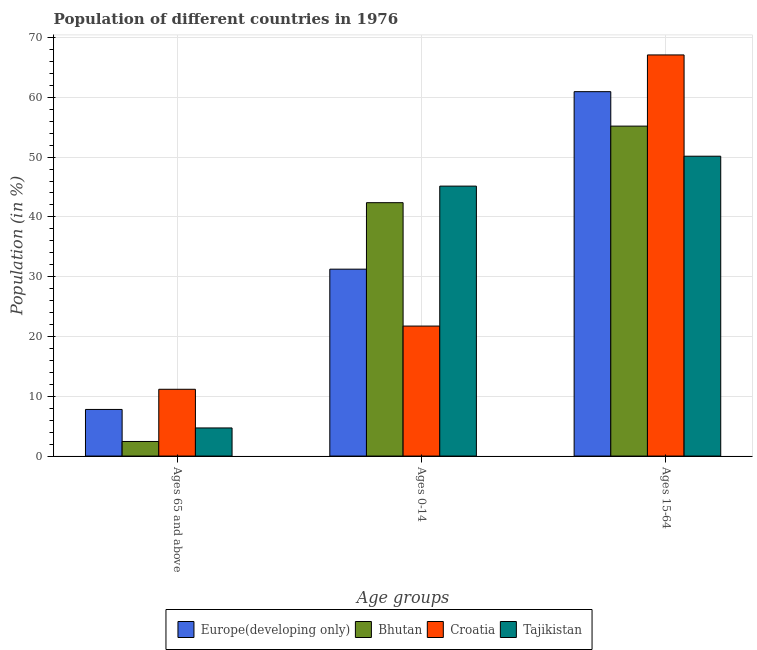How many groups of bars are there?
Keep it short and to the point. 3. Are the number of bars per tick equal to the number of legend labels?
Keep it short and to the point. Yes. How many bars are there on the 1st tick from the left?
Make the answer very short. 4. What is the label of the 2nd group of bars from the left?
Your response must be concise. Ages 0-14. What is the percentage of population within the age-group 15-64 in Tajikistan?
Your response must be concise. 50.15. Across all countries, what is the maximum percentage of population within the age-group of 65 and above?
Your answer should be compact. 11.17. Across all countries, what is the minimum percentage of population within the age-group 15-64?
Keep it short and to the point. 50.15. In which country was the percentage of population within the age-group of 65 and above maximum?
Offer a terse response. Croatia. In which country was the percentage of population within the age-group 0-14 minimum?
Ensure brevity in your answer.  Croatia. What is the total percentage of population within the age-group 15-64 in the graph?
Offer a terse response. 233.36. What is the difference between the percentage of population within the age-group 15-64 in Bhutan and that in Croatia?
Provide a short and direct response. -11.91. What is the difference between the percentage of population within the age-group of 65 and above in Tajikistan and the percentage of population within the age-group 0-14 in Europe(developing only)?
Offer a very short reply. -26.55. What is the average percentage of population within the age-group 15-64 per country?
Your answer should be compact. 58.34. What is the difference between the percentage of population within the age-group 15-64 and percentage of population within the age-group of 65 and above in Bhutan?
Offer a very short reply. 52.74. What is the ratio of the percentage of population within the age-group of 65 and above in Croatia to that in Europe(developing only)?
Keep it short and to the point. 1.43. Is the difference between the percentage of population within the age-group of 65 and above in Bhutan and Tajikistan greater than the difference between the percentage of population within the age-group 0-14 in Bhutan and Tajikistan?
Your answer should be very brief. Yes. What is the difference between the highest and the second highest percentage of population within the age-group of 65 and above?
Make the answer very short. 3.37. What is the difference between the highest and the lowest percentage of population within the age-group 0-14?
Your answer should be very brief. 23.41. Is the sum of the percentage of population within the age-group of 65 and above in Croatia and Europe(developing only) greater than the maximum percentage of population within the age-group 15-64 across all countries?
Ensure brevity in your answer.  No. What does the 3rd bar from the left in Ages 65 and above represents?
Provide a short and direct response. Croatia. What does the 1st bar from the right in Ages 65 and above represents?
Keep it short and to the point. Tajikistan. How many bars are there?
Provide a short and direct response. 12. Are all the bars in the graph horizontal?
Your response must be concise. No. What is the difference between two consecutive major ticks on the Y-axis?
Offer a very short reply. 10. Are the values on the major ticks of Y-axis written in scientific E-notation?
Give a very brief answer. No. Does the graph contain any zero values?
Provide a short and direct response. No. Where does the legend appear in the graph?
Give a very brief answer. Bottom center. What is the title of the graph?
Give a very brief answer. Population of different countries in 1976. Does "Tunisia" appear as one of the legend labels in the graph?
Offer a terse response. No. What is the label or title of the X-axis?
Give a very brief answer. Age groups. What is the label or title of the Y-axis?
Ensure brevity in your answer.  Population (in %). What is the Population (in %) of Europe(developing only) in Ages 65 and above?
Make the answer very short. 7.8. What is the Population (in %) in Bhutan in Ages 65 and above?
Make the answer very short. 2.44. What is the Population (in %) in Croatia in Ages 65 and above?
Provide a succinct answer. 11.17. What is the Population (in %) in Tajikistan in Ages 65 and above?
Your answer should be compact. 4.7. What is the Population (in %) in Europe(developing only) in Ages 0-14?
Make the answer very short. 31.26. What is the Population (in %) in Bhutan in Ages 0-14?
Give a very brief answer. 42.38. What is the Population (in %) of Croatia in Ages 0-14?
Offer a very short reply. 21.74. What is the Population (in %) of Tajikistan in Ages 0-14?
Ensure brevity in your answer.  45.15. What is the Population (in %) of Europe(developing only) in Ages 15-64?
Offer a very short reply. 60.94. What is the Population (in %) of Bhutan in Ages 15-64?
Provide a short and direct response. 55.18. What is the Population (in %) of Croatia in Ages 15-64?
Your answer should be compact. 67.09. What is the Population (in %) in Tajikistan in Ages 15-64?
Provide a succinct answer. 50.15. Across all Age groups, what is the maximum Population (in %) in Europe(developing only)?
Provide a succinct answer. 60.94. Across all Age groups, what is the maximum Population (in %) in Bhutan?
Ensure brevity in your answer.  55.18. Across all Age groups, what is the maximum Population (in %) in Croatia?
Offer a terse response. 67.09. Across all Age groups, what is the maximum Population (in %) of Tajikistan?
Provide a short and direct response. 50.15. Across all Age groups, what is the minimum Population (in %) in Europe(developing only)?
Keep it short and to the point. 7.8. Across all Age groups, what is the minimum Population (in %) of Bhutan?
Provide a succinct answer. 2.44. Across all Age groups, what is the minimum Population (in %) in Croatia?
Provide a succinct answer. 11.17. Across all Age groups, what is the minimum Population (in %) of Tajikistan?
Your answer should be very brief. 4.7. What is the total Population (in %) in Bhutan in the graph?
Provide a short and direct response. 100. What is the difference between the Population (in %) of Europe(developing only) in Ages 65 and above and that in Ages 0-14?
Give a very brief answer. -23.46. What is the difference between the Population (in %) in Bhutan in Ages 65 and above and that in Ages 0-14?
Your answer should be very brief. -39.94. What is the difference between the Population (in %) in Croatia in Ages 65 and above and that in Ages 0-14?
Make the answer very short. -10.57. What is the difference between the Population (in %) of Tajikistan in Ages 65 and above and that in Ages 0-14?
Provide a succinct answer. -40.44. What is the difference between the Population (in %) of Europe(developing only) in Ages 65 and above and that in Ages 15-64?
Keep it short and to the point. -53.15. What is the difference between the Population (in %) of Bhutan in Ages 65 and above and that in Ages 15-64?
Offer a very short reply. -52.74. What is the difference between the Population (in %) of Croatia in Ages 65 and above and that in Ages 15-64?
Your response must be concise. -55.92. What is the difference between the Population (in %) in Tajikistan in Ages 65 and above and that in Ages 15-64?
Your response must be concise. -45.45. What is the difference between the Population (in %) in Europe(developing only) in Ages 0-14 and that in Ages 15-64?
Make the answer very short. -29.69. What is the difference between the Population (in %) in Bhutan in Ages 0-14 and that in Ages 15-64?
Offer a terse response. -12.8. What is the difference between the Population (in %) of Croatia in Ages 0-14 and that in Ages 15-64?
Keep it short and to the point. -45.35. What is the difference between the Population (in %) of Tajikistan in Ages 0-14 and that in Ages 15-64?
Provide a short and direct response. -5. What is the difference between the Population (in %) of Europe(developing only) in Ages 65 and above and the Population (in %) of Bhutan in Ages 0-14?
Keep it short and to the point. -34.58. What is the difference between the Population (in %) in Europe(developing only) in Ages 65 and above and the Population (in %) in Croatia in Ages 0-14?
Ensure brevity in your answer.  -13.94. What is the difference between the Population (in %) in Europe(developing only) in Ages 65 and above and the Population (in %) in Tajikistan in Ages 0-14?
Offer a terse response. -37.35. What is the difference between the Population (in %) in Bhutan in Ages 65 and above and the Population (in %) in Croatia in Ages 0-14?
Ensure brevity in your answer.  -19.3. What is the difference between the Population (in %) in Bhutan in Ages 65 and above and the Population (in %) in Tajikistan in Ages 0-14?
Provide a succinct answer. -42.71. What is the difference between the Population (in %) in Croatia in Ages 65 and above and the Population (in %) in Tajikistan in Ages 0-14?
Your response must be concise. -33.98. What is the difference between the Population (in %) in Europe(developing only) in Ages 65 and above and the Population (in %) in Bhutan in Ages 15-64?
Provide a succinct answer. -47.38. What is the difference between the Population (in %) in Europe(developing only) in Ages 65 and above and the Population (in %) in Croatia in Ages 15-64?
Provide a succinct answer. -59.29. What is the difference between the Population (in %) of Europe(developing only) in Ages 65 and above and the Population (in %) of Tajikistan in Ages 15-64?
Your answer should be compact. -42.35. What is the difference between the Population (in %) of Bhutan in Ages 65 and above and the Population (in %) of Croatia in Ages 15-64?
Your answer should be compact. -64.65. What is the difference between the Population (in %) in Bhutan in Ages 65 and above and the Population (in %) in Tajikistan in Ages 15-64?
Offer a terse response. -47.71. What is the difference between the Population (in %) of Croatia in Ages 65 and above and the Population (in %) of Tajikistan in Ages 15-64?
Provide a short and direct response. -38.98. What is the difference between the Population (in %) in Europe(developing only) in Ages 0-14 and the Population (in %) in Bhutan in Ages 15-64?
Ensure brevity in your answer.  -23.92. What is the difference between the Population (in %) in Europe(developing only) in Ages 0-14 and the Population (in %) in Croatia in Ages 15-64?
Make the answer very short. -35.83. What is the difference between the Population (in %) in Europe(developing only) in Ages 0-14 and the Population (in %) in Tajikistan in Ages 15-64?
Your response must be concise. -18.89. What is the difference between the Population (in %) in Bhutan in Ages 0-14 and the Population (in %) in Croatia in Ages 15-64?
Offer a very short reply. -24.71. What is the difference between the Population (in %) in Bhutan in Ages 0-14 and the Population (in %) in Tajikistan in Ages 15-64?
Provide a short and direct response. -7.77. What is the difference between the Population (in %) of Croatia in Ages 0-14 and the Population (in %) of Tajikistan in Ages 15-64?
Offer a terse response. -28.41. What is the average Population (in %) of Europe(developing only) per Age groups?
Keep it short and to the point. 33.33. What is the average Population (in %) in Bhutan per Age groups?
Provide a short and direct response. 33.33. What is the average Population (in %) in Croatia per Age groups?
Your answer should be very brief. 33.33. What is the average Population (in %) in Tajikistan per Age groups?
Offer a very short reply. 33.33. What is the difference between the Population (in %) of Europe(developing only) and Population (in %) of Bhutan in Ages 65 and above?
Offer a terse response. 5.36. What is the difference between the Population (in %) of Europe(developing only) and Population (in %) of Croatia in Ages 65 and above?
Give a very brief answer. -3.37. What is the difference between the Population (in %) of Europe(developing only) and Population (in %) of Tajikistan in Ages 65 and above?
Provide a short and direct response. 3.09. What is the difference between the Population (in %) of Bhutan and Population (in %) of Croatia in Ages 65 and above?
Your response must be concise. -8.73. What is the difference between the Population (in %) of Bhutan and Population (in %) of Tajikistan in Ages 65 and above?
Give a very brief answer. -2.26. What is the difference between the Population (in %) of Croatia and Population (in %) of Tajikistan in Ages 65 and above?
Offer a terse response. 6.47. What is the difference between the Population (in %) of Europe(developing only) and Population (in %) of Bhutan in Ages 0-14?
Offer a very short reply. -11.12. What is the difference between the Population (in %) in Europe(developing only) and Population (in %) in Croatia in Ages 0-14?
Ensure brevity in your answer.  9.52. What is the difference between the Population (in %) of Europe(developing only) and Population (in %) of Tajikistan in Ages 0-14?
Keep it short and to the point. -13.89. What is the difference between the Population (in %) in Bhutan and Population (in %) in Croatia in Ages 0-14?
Your answer should be compact. 20.64. What is the difference between the Population (in %) of Bhutan and Population (in %) of Tajikistan in Ages 0-14?
Provide a succinct answer. -2.77. What is the difference between the Population (in %) in Croatia and Population (in %) in Tajikistan in Ages 0-14?
Offer a very short reply. -23.41. What is the difference between the Population (in %) of Europe(developing only) and Population (in %) of Bhutan in Ages 15-64?
Offer a very short reply. 5.76. What is the difference between the Population (in %) in Europe(developing only) and Population (in %) in Croatia in Ages 15-64?
Your answer should be compact. -6.14. What is the difference between the Population (in %) of Europe(developing only) and Population (in %) of Tajikistan in Ages 15-64?
Make the answer very short. 10.79. What is the difference between the Population (in %) of Bhutan and Population (in %) of Croatia in Ages 15-64?
Give a very brief answer. -11.91. What is the difference between the Population (in %) of Bhutan and Population (in %) of Tajikistan in Ages 15-64?
Provide a short and direct response. 5.03. What is the difference between the Population (in %) in Croatia and Population (in %) in Tajikistan in Ages 15-64?
Keep it short and to the point. 16.94. What is the ratio of the Population (in %) of Europe(developing only) in Ages 65 and above to that in Ages 0-14?
Keep it short and to the point. 0.25. What is the ratio of the Population (in %) of Bhutan in Ages 65 and above to that in Ages 0-14?
Offer a terse response. 0.06. What is the ratio of the Population (in %) in Croatia in Ages 65 and above to that in Ages 0-14?
Make the answer very short. 0.51. What is the ratio of the Population (in %) of Tajikistan in Ages 65 and above to that in Ages 0-14?
Ensure brevity in your answer.  0.1. What is the ratio of the Population (in %) in Europe(developing only) in Ages 65 and above to that in Ages 15-64?
Offer a very short reply. 0.13. What is the ratio of the Population (in %) in Bhutan in Ages 65 and above to that in Ages 15-64?
Your answer should be very brief. 0.04. What is the ratio of the Population (in %) in Croatia in Ages 65 and above to that in Ages 15-64?
Ensure brevity in your answer.  0.17. What is the ratio of the Population (in %) in Tajikistan in Ages 65 and above to that in Ages 15-64?
Ensure brevity in your answer.  0.09. What is the ratio of the Population (in %) of Europe(developing only) in Ages 0-14 to that in Ages 15-64?
Ensure brevity in your answer.  0.51. What is the ratio of the Population (in %) in Bhutan in Ages 0-14 to that in Ages 15-64?
Keep it short and to the point. 0.77. What is the ratio of the Population (in %) of Croatia in Ages 0-14 to that in Ages 15-64?
Offer a very short reply. 0.32. What is the ratio of the Population (in %) in Tajikistan in Ages 0-14 to that in Ages 15-64?
Offer a very short reply. 0.9. What is the difference between the highest and the second highest Population (in %) of Europe(developing only)?
Keep it short and to the point. 29.69. What is the difference between the highest and the second highest Population (in %) of Bhutan?
Your answer should be compact. 12.8. What is the difference between the highest and the second highest Population (in %) in Croatia?
Your answer should be compact. 45.35. What is the difference between the highest and the second highest Population (in %) of Tajikistan?
Provide a succinct answer. 5. What is the difference between the highest and the lowest Population (in %) of Europe(developing only)?
Offer a terse response. 53.15. What is the difference between the highest and the lowest Population (in %) of Bhutan?
Offer a very short reply. 52.74. What is the difference between the highest and the lowest Population (in %) of Croatia?
Give a very brief answer. 55.92. What is the difference between the highest and the lowest Population (in %) of Tajikistan?
Keep it short and to the point. 45.45. 